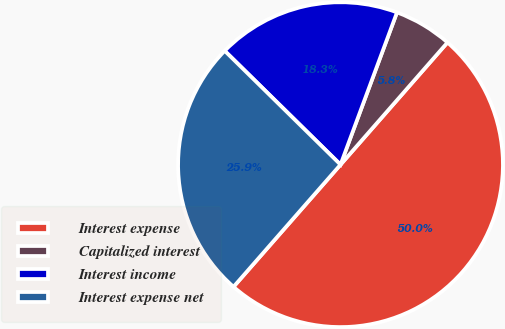Convert chart to OTSL. <chart><loc_0><loc_0><loc_500><loc_500><pie_chart><fcel>Interest expense<fcel>Capitalized interest<fcel>Interest income<fcel>Interest expense net<nl><fcel>50.0%<fcel>5.79%<fcel>18.29%<fcel>25.91%<nl></chart> 